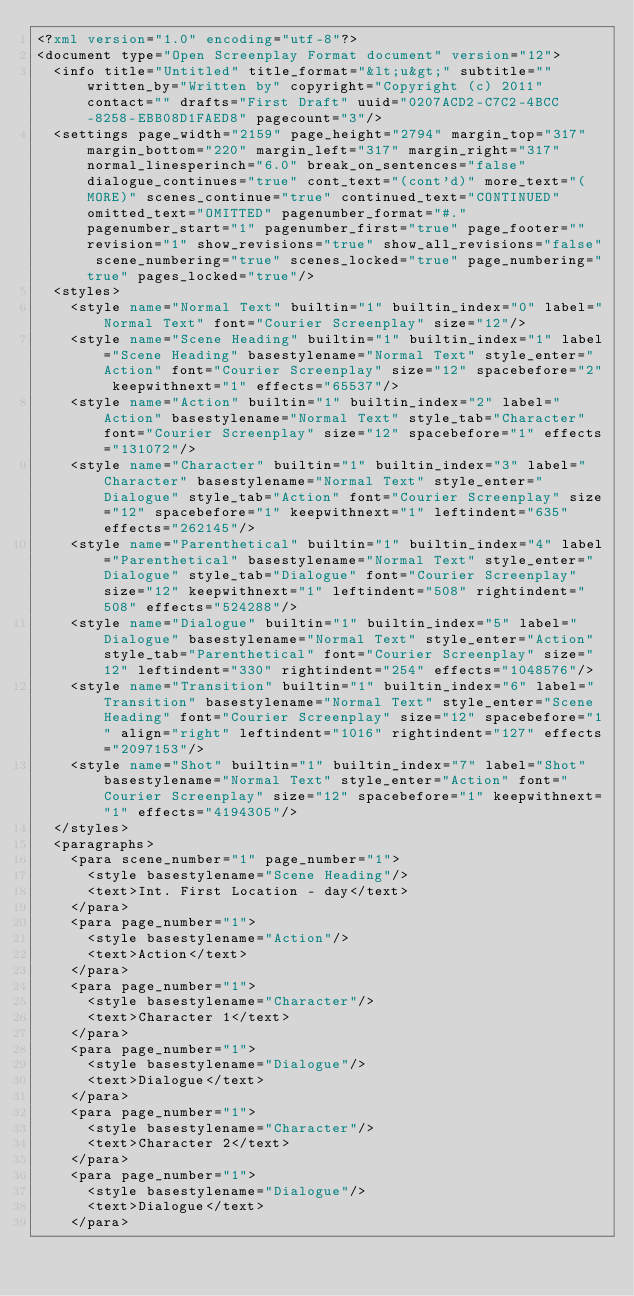Convert code to text. <code><loc_0><loc_0><loc_500><loc_500><_XML_><?xml version="1.0" encoding="utf-8"?>
<document type="Open Screenplay Format document" version="12">
  <info title="Untitled" title_format="&lt;u&gt;" subtitle="" written_by="Written by" copyright="Copyright (c) 2011" contact="" drafts="First Draft" uuid="0207ACD2-C7C2-4BCC-8258-EBB08D1FAED8" pagecount="3"/>
  <settings page_width="2159" page_height="2794" margin_top="317" margin_bottom="220" margin_left="317" margin_right="317" normal_linesperinch="6.0" break_on_sentences="false" dialogue_continues="true" cont_text="(cont'd)" more_text="(MORE)" scenes_continue="true" continued_text="CONTINUED" omitted_text="OMITTED" pagenumber_format="#." pagenumber_start="1" pagenumber_first="true" page_footer="" revision="1" show_revisions="true" show_all_revisions="false" scene_numbering="true" scenes_locked="true" page_numbering="true" pages_locked="true"/>
  <styles>
    <style name="Normal Text" builtin="1" builtin_index="0" label="Normal Text" font="Courier Screenplay" size="12"/>
    <style name="Scene Heading" builtin="1" builtin_index="1" label="Scene Heading" basestylename="Normal Text" style_enter="Action" font="Courier Screenplay" size="12" spacebefore="2" keepwithnext="1" effects="65537"/>
    <style name="Action" builtin="1" builtin_index="2" label="Action" basestylename="Normal Text" style_tab="Character" font="Courier Screenplay" size="12" spacebefore="1" effects="131072"/>
    <style name="Character" builtin="1" builtin_index="3" label="Character" basestylename="Normal Text" style_enter="Dialogue" style_tab="Action" font="Courier Screenplay" size="12" spacebefore="1" keepwithnext="1" leftindent="635" effects="262145"/>
    <style name="Parenthetical" builtin="1" builtin_index="4" label="Parenthetical" basestylename="Normal Text" style_enter="Dialogue" style_tab="Dialogue" font="Courier Screenplay" size="12" keepwithnext="1" leftindent="508" rightindent="508" effects="524288"/>
    <style name="Dialogue" builtin="1" builtin_index="5" label="Dialogue" basestylename="Normal Text" style_enter="Action" style_tab="Parenthetical" font="Courier Screenplay" size="12" leftindent="330" rightindent="254" effects="1048576"/>
    <style name="Transition" builtin="1" builtin_index="6" label="Transition" basestylename="Normal Text" style_enter="Scene Heading" font="Courier Screenplay" size="12" spacebefore="1" align="right" leftindent="1016" rightindent="127" effects="2097153"/>
    <style name="Shot" builtin="1" builtin_index="7" label="Shot" basestylename="Normal Text" style_enter="Action" font="Courier Screenplay" size="12" spacebefore="1" keepwithnext="1" effects="4194305"/>
  </styles>
  <paragraphs>
    <para scene_number="1" page_number="1">
      <style basestylename="Scene Heading"/>
      <text>Int. First Location - day</text>
    </para>
    <para page_number="1">
      <style basestylename="Action"/>
      <text>Action</text>
    </para>
    <para page_number="1">
      <style basestylename="Character"/>
      <text>Character 1</text>
    </para>
    <para page_number="1">
      <style basestylename="Dialogue"/>
      <text>Dialogue</text>
    </para>
    <para page_number="1">
      <style basestylename="Character"/>
      <text>Character 2</text>
    </para>
    <para page_number="1">
      <style basestylename="Dialogue"/>
      <text>Dialogue</text>
    </para></code> 